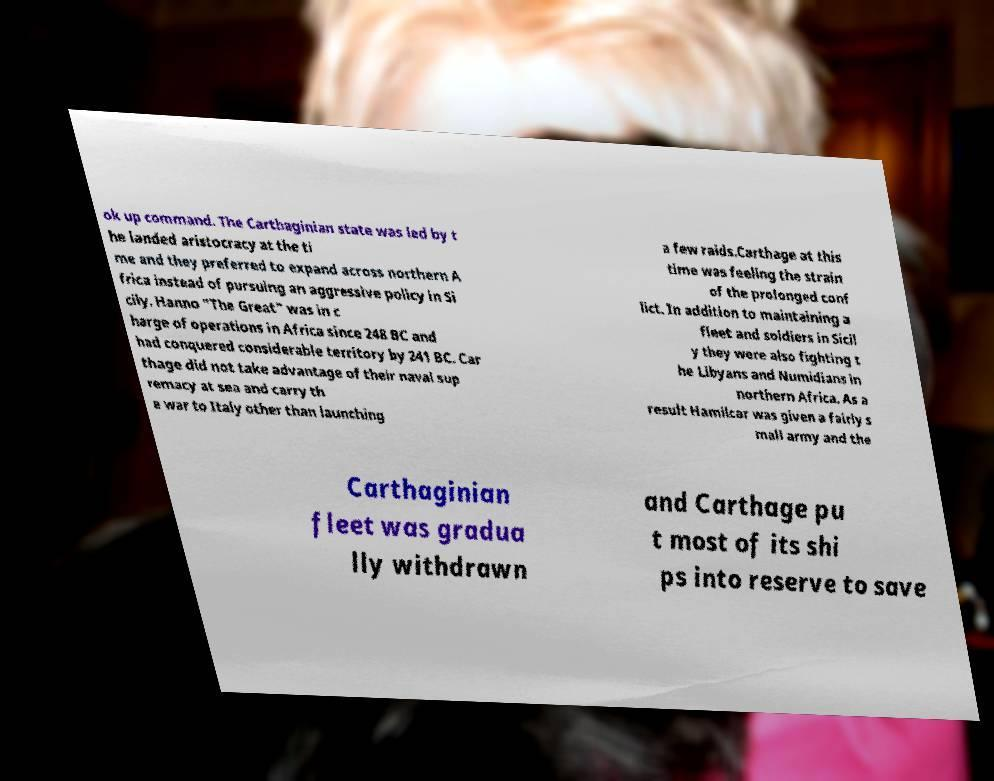Could you extract and type out the text from this image? ok up command. The Carthaginian state was led by t he landed aristocracy at the ti me and they preferred to expand across northern A frica instead of pursuing an aggressive policy in Si cily. Hanno "The Great" was in c harge of operations in Africa since 248 BC and had conquered considerable territory by 241 BC. Car thage did not take advantage of their naval sup remacy at sea and carry th e war to Italy other than launching a few raids.Carthage at this time was feeling the strain of the prolonged conf lict. In addition to maintaining a fleet and soldiers in Sicil y they were also fighting t he Libyans and Numidians in northern Africa. As a result Hamilcar was given a fairly s mall army and the Carthaginian fleet was gradua lly withdrawn and Carthage pu t most of its shi ps into reserve to save 